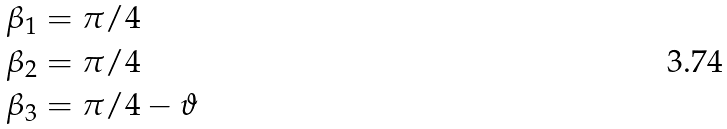<formula> <loc_0><loc_0><loc_500><loc_500>\beta _ { 1 } & = \pi / 4 \\ \beta _ { 2 } & = \pi / 4 \\ \beta _ { 3 } & = \pi / 4 - \vartheta</formula> 